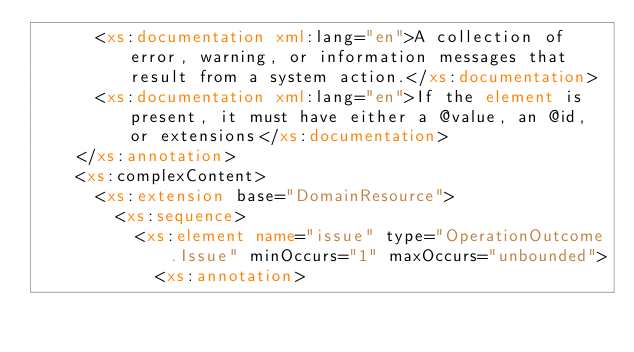Convert code to text. <code><loc_0><loc_0><loc_500><loc_500><_XML_>      <xs:documentation xml:lang="en">A collection of error, warning, or information messages that result from a system action.</xs:documentation>
      <xs:documentation xml:lang="en">If the element is present, it must have either a @value, an @id, or extensions</xs:documentation>
    </xs:annotation>
    <xs:complexContent>
      <xs:extension base="DomainResource">
        <xs:sequence>
          <xs:element name="issue" type="OperationOutcome.Issue" minOccurs="1" maxOccurs="unbounded">
            <xs:annotation></code> 